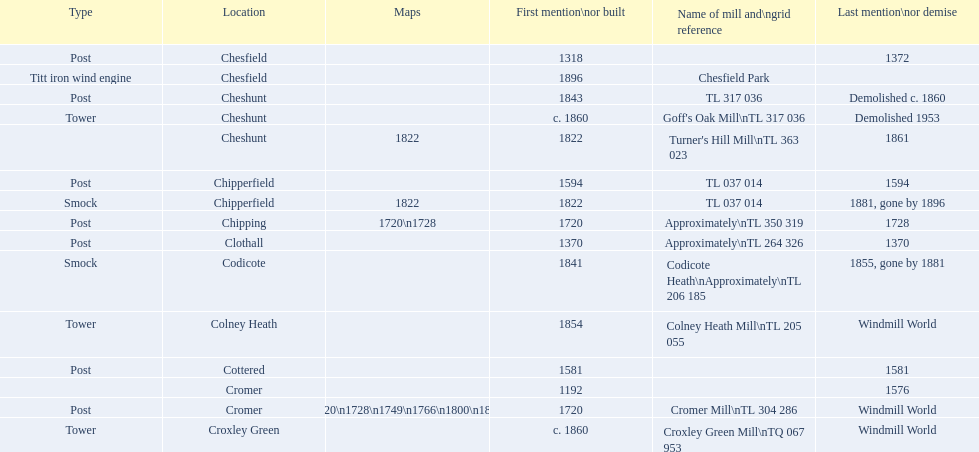What is the total number of mills named cheshunt? 3. 